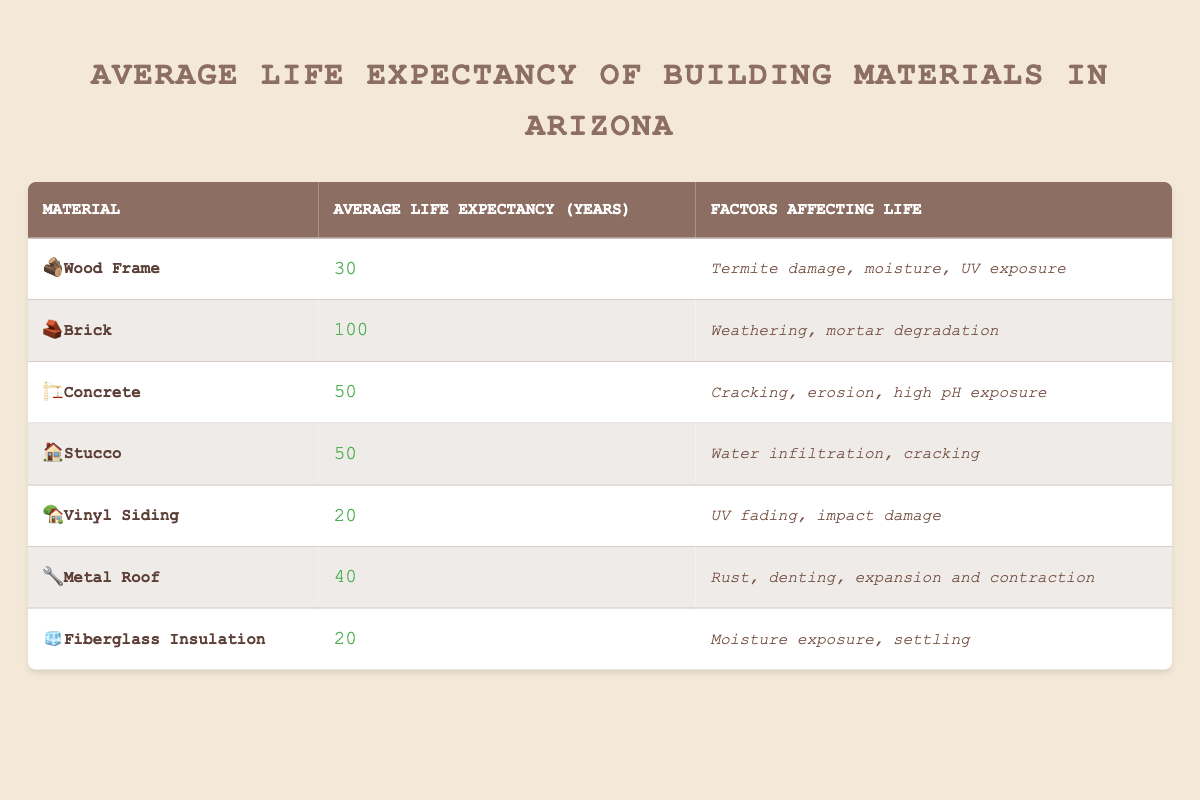What is the average life expectancy of Wood Frame? The table lists the average life expectancy for Wood Frame as 30 years.
Answer: 30 years Which material has the longest average life expectancy? Reviewing the table, Brick has the longest average life expectancy at 100 years compared to others.
Answer: Brick What is the total life expectancy of Concrete and Stucco combined? Adding the life expectancies of Concrete (50 years) and Stucco (50 years) gives a total of 100 years (50 + 50 = 100).
Answer: 100 years Is the average life expectancy of Vinyl Siding greater than that of Fiberglass Insulation? The table shows Vinyl Siding has an average life expectancy of 20 years, while Fiberglass Insulation also has 20 years, so they are equal.
Answer: No What is the difference in average life expectancy between a Metal Roof and a Vinyl Siding? The average life expectancy of a Metal Roof is 40 years, and Vinyl Siding is 20 years. The difference is 20 years (40 - 20 = 20).
Answer: 20 years Which materials have an average life expectancy of 50 years? The table indicates that both Concrete and Stucco have an average life expectancy of 50 years.
Answer: Concrete and Stucco What is the average life expectancy of all the materials listed? To find the average, sum the life expectancies: (30 + 100 + 50 + 50 + 20 + 40 + 20) = 310, then divide by 7 materials to get approximately 44.29 years (310/7 = 44.29).
Answer: 44.29 years Does any material have factors affecting its life that include moisture? Yes, both Wood Frame and Fiberglass Insulation have moisture listed as a factor affecting their life.
Answer: Yes Which material is most vulnerable to UV exposure? The table shows that Wood Frame and Vinyl Siding have UV exposure listed as a factor affecting their life, making them vulnerable.
Answer: Wood Frame and Vinyl Siding 